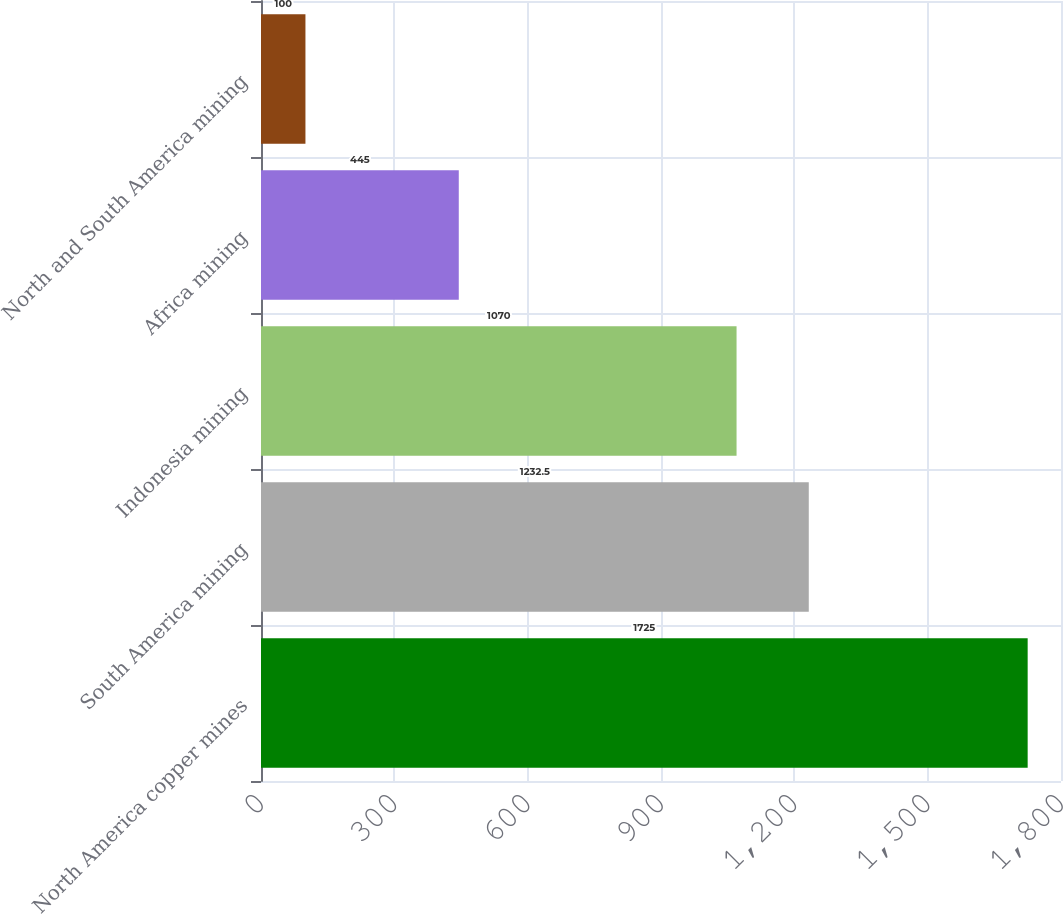<chart> <loc_0><loc_0><loc_500><loc_500><bar_chart><fcel>North America copper mines<fcel>South America mining<fcel>Indonesia mining<fcel>Africa mining<fcel>North and South America mining<nl><fcel>1725<fcel>1232.5<fcel>1070<fcel>445<fcel>100<nl></chart> 